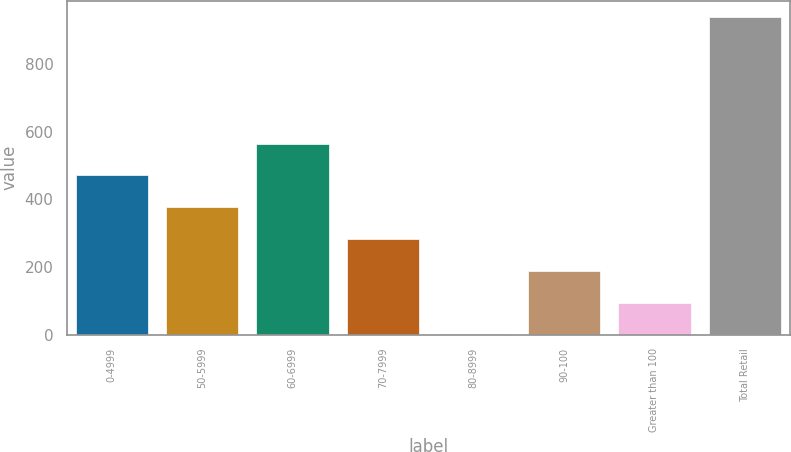Convert chart. <chart><loc_0><loc_0><loc_500><loc_500><bar_chart><fcel>0-4999<fcel>50-5999<fcel>60-6999<fcel>70-7999<fcel>80-8999<fcel>90-100<fcel>Greater than 100<fcel>Total Retail<nl><fcel>470.76<fcel>376.91<fcel>564.61<fcel>283.06<fcel>1.51<fcel>189.21<fcel>95.36<fcel>940<nl></chart> 